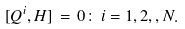Convert formula to latex. <formula><loc_0><loc_0><loc_500><loc_500>[ Q ^ { i } , H ] \, = \, 0 \colon \, i = 1 , 2 , , N .</formula> 